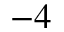<formula> <loc_0><loc_0><loc_500><loc_500>^ { - 4 }</formula> 